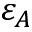Convert formula to latex. <formula><loc_0><loc_0><loc_500><loc_500>\varepsilon _ { A }</formula> 